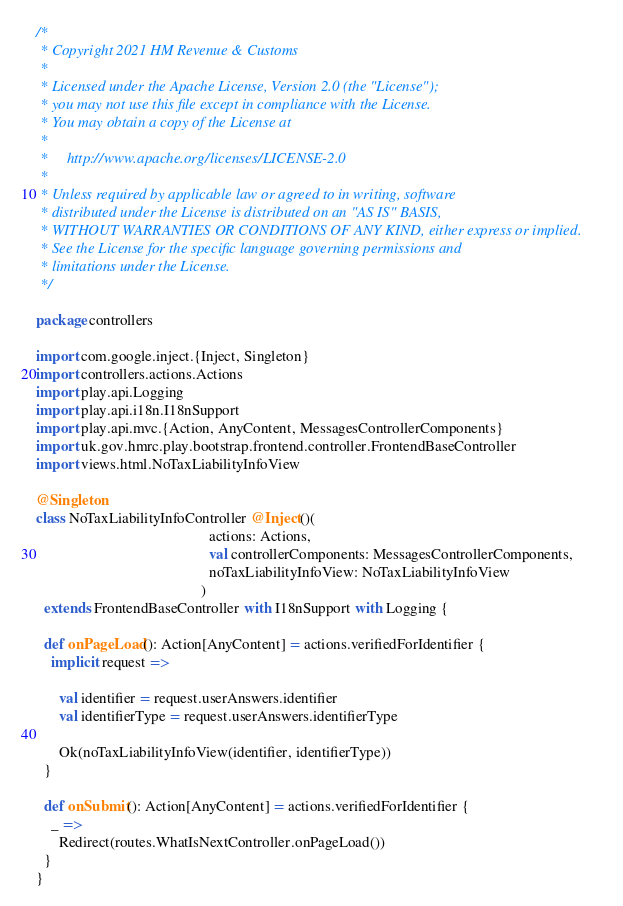<code> <loc_0><loc_0><loc_500><loc_500><_Scala_>/*
 * Copyright 2021 HM Revenue & Customs
 *
 * Licensed under the Apache License, Version 2.0 (the "License");
 * you may not use this file except in compliance with the License.
 * You may obtain a copy of the License at
 *
 *     http://www.apache.org/licenses/LICENSE-2.0
 *
 * Unless required by applicable law or agreed to in writing, software
 * distributed under the License is distributed on an "AS IS" BASIS,
 * WITHOUT WARRANTIES OR CONDITIONS OF ANY KIND, either express or implied.
 * See the License for the specific language governing permissions and
 * limitations under the License.
 */

package controllers

import com.google.inject.{Inject, Singleton}
import controllers.actions.Actions
import play.api.Logging
import play.api.i18n.I18nSupport
import play.api.mvc.{Action, AnyContent, MessagesControllerComponents}
import uk.gov.hmrc.play.bootstrap.frontend.controller.FrontendBaseController
import views.html.NoTaxLiabilityInfoView

@Singleton
class NoTaxLiabilityInfoController @Inject()(
                                              actions: Actions,
                                              val controllerComponents: MessagesControllerComponents,
                                              noTaxLiabilityInfoView: NoTaxLiabilityInfoView
                                            )
  extends FrontendBaseController with I18nSupport with Logging {

  def onPageLoad(): Action[AnyContent] = actions.verifiedForIdentifier {
    implicit request =>

      val identifier = request.userAnswers.identifier
      val identifierType = request.userAnswers.identifierType

      Ok(noTaxLiabilityInfoView(identifier, identifierType))
  }

  def onSubmit(): Action[AnyContent] = actions.verifiedForIdentifier {
    _ =>
      Redirect(routes.WhatIsNextController.onPageLoad())
  }
}
</code> 